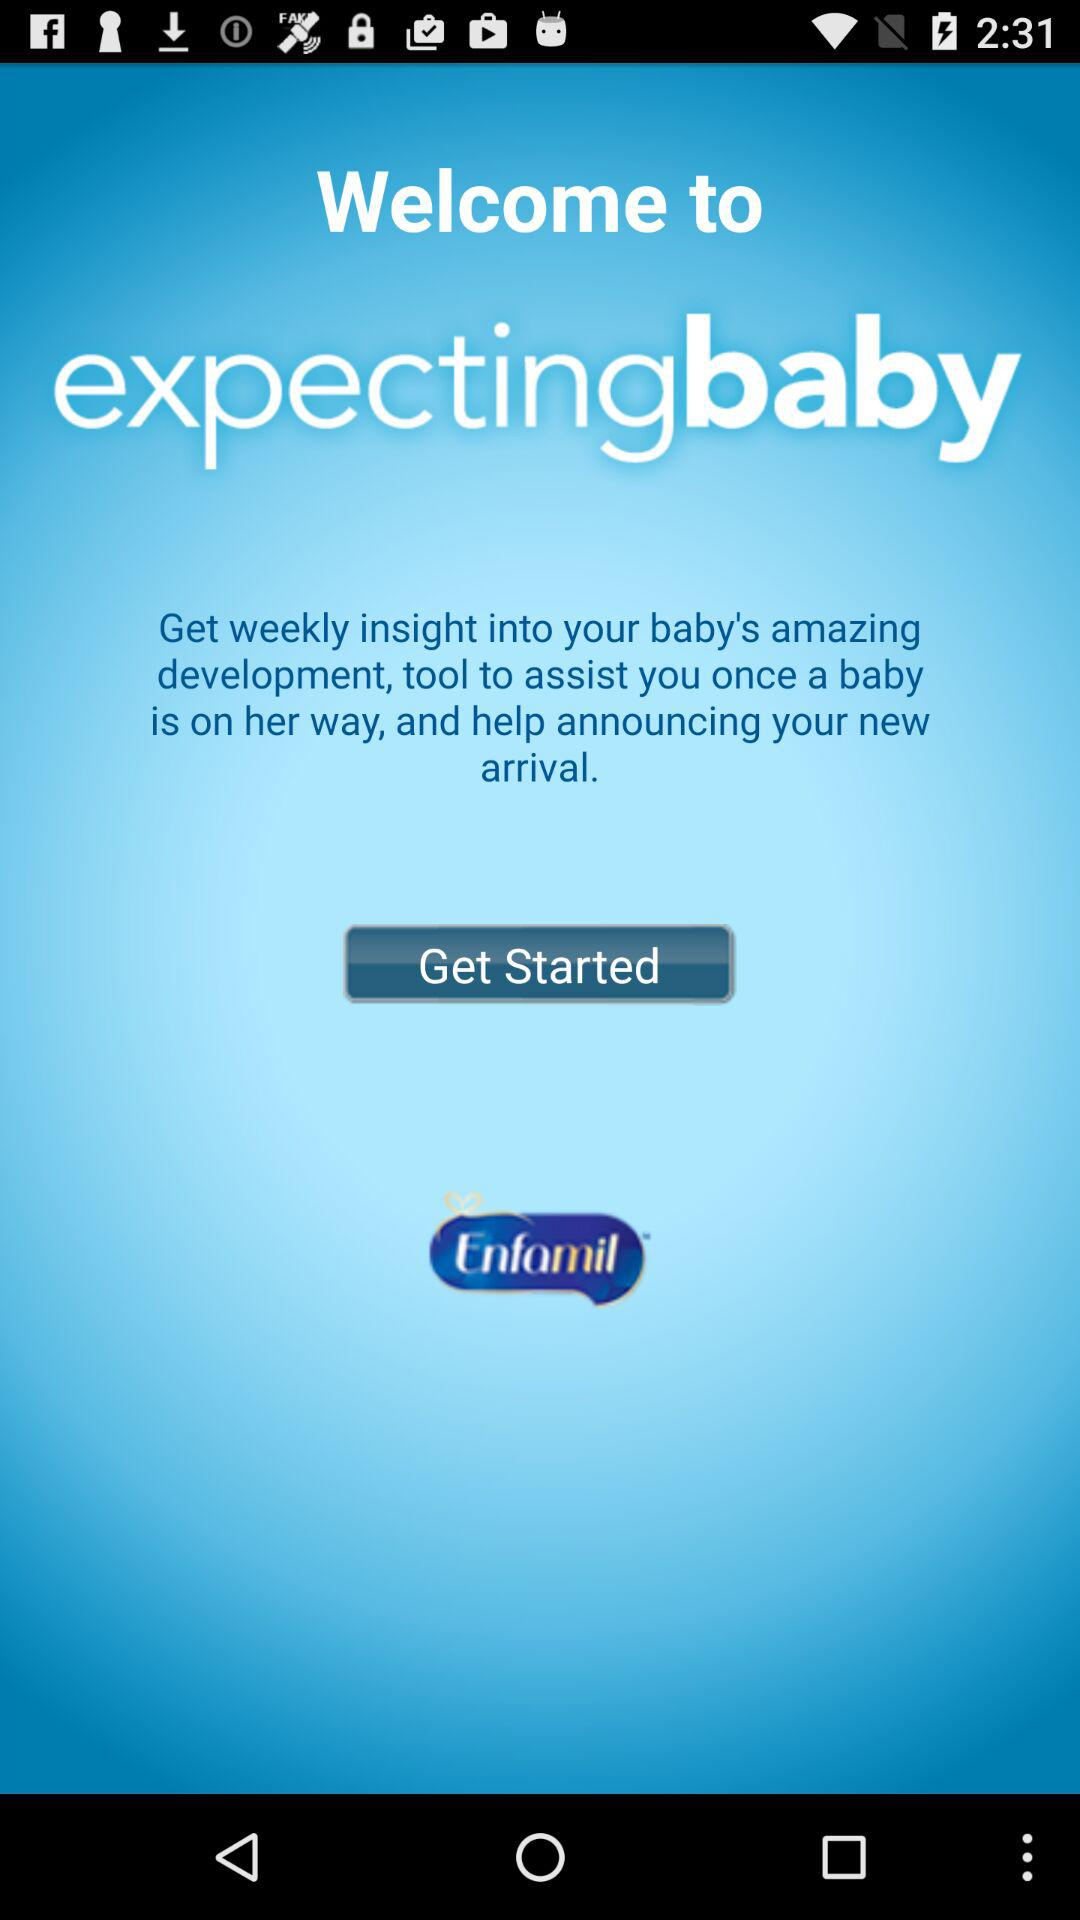What is the name of the application? The name of the application is "expectingbaby". 